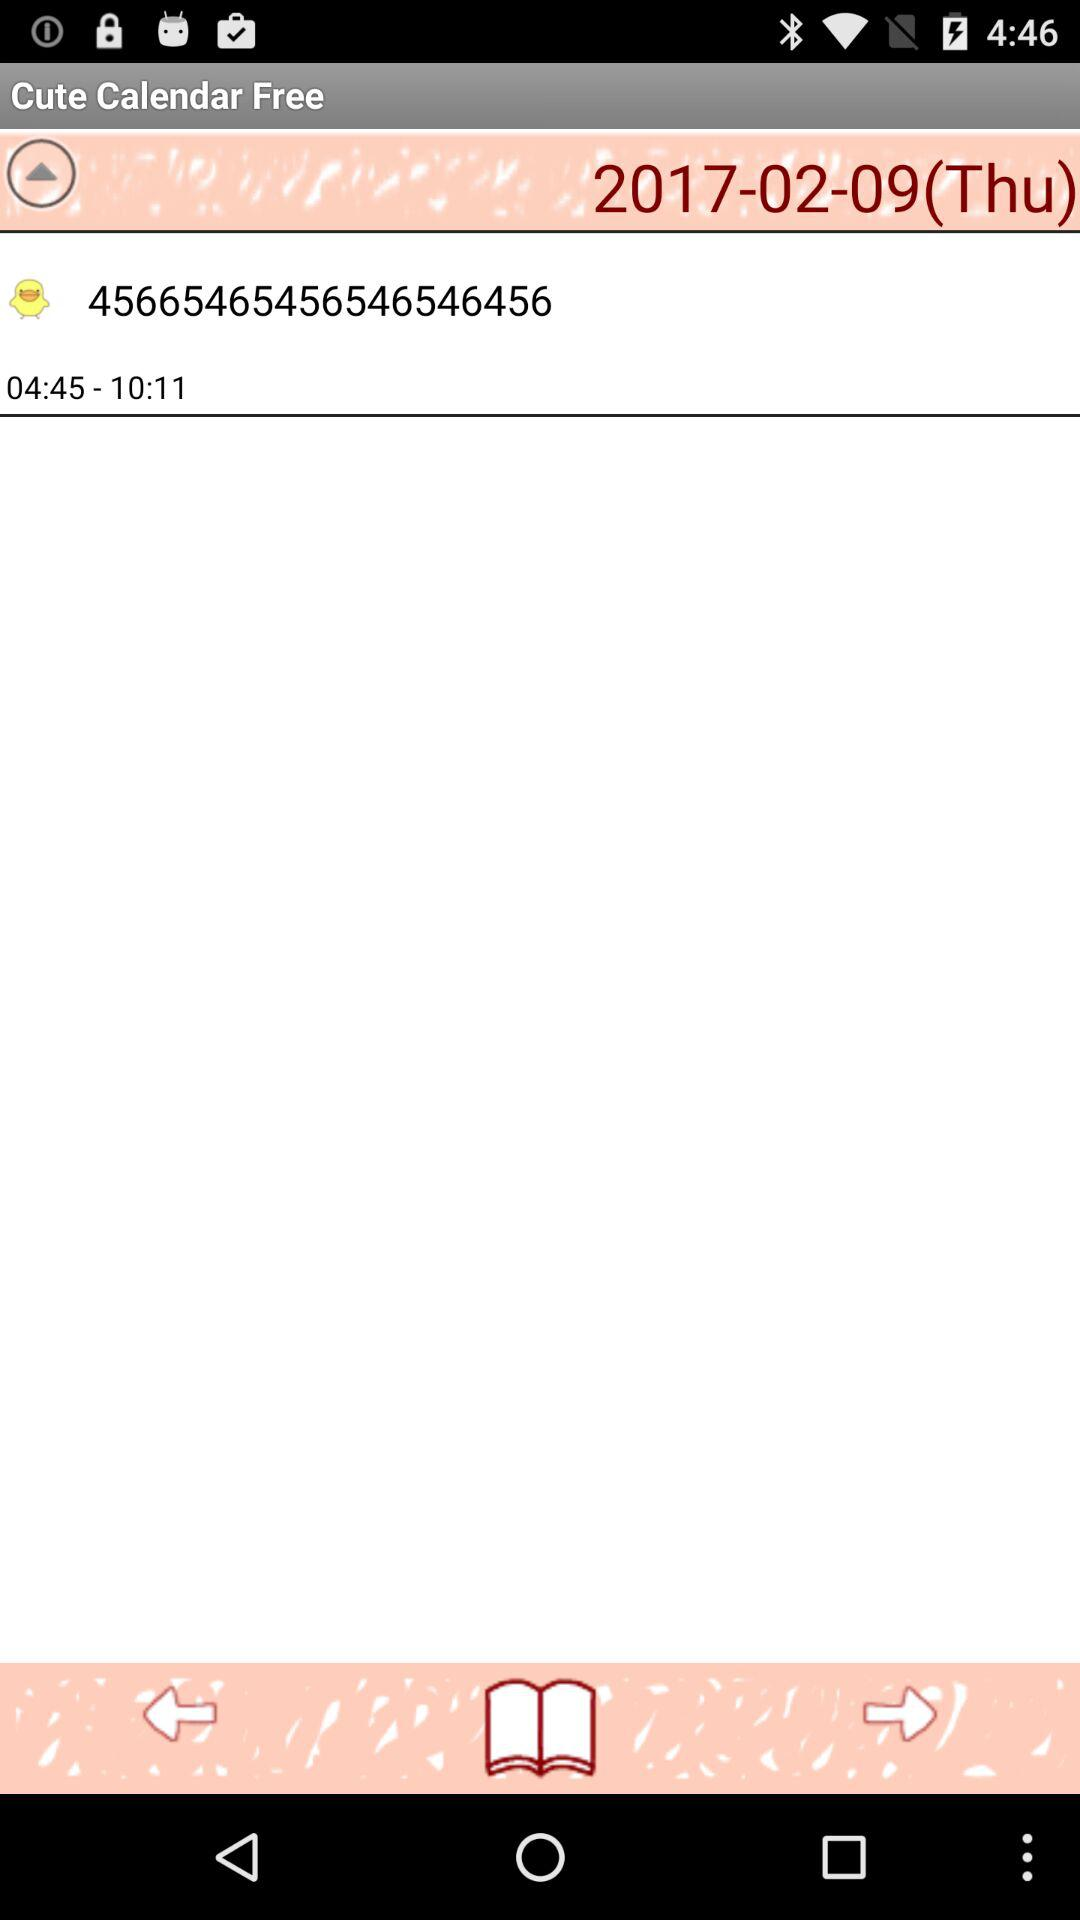What's the selected time range? The time range is 04:45-10:11. 